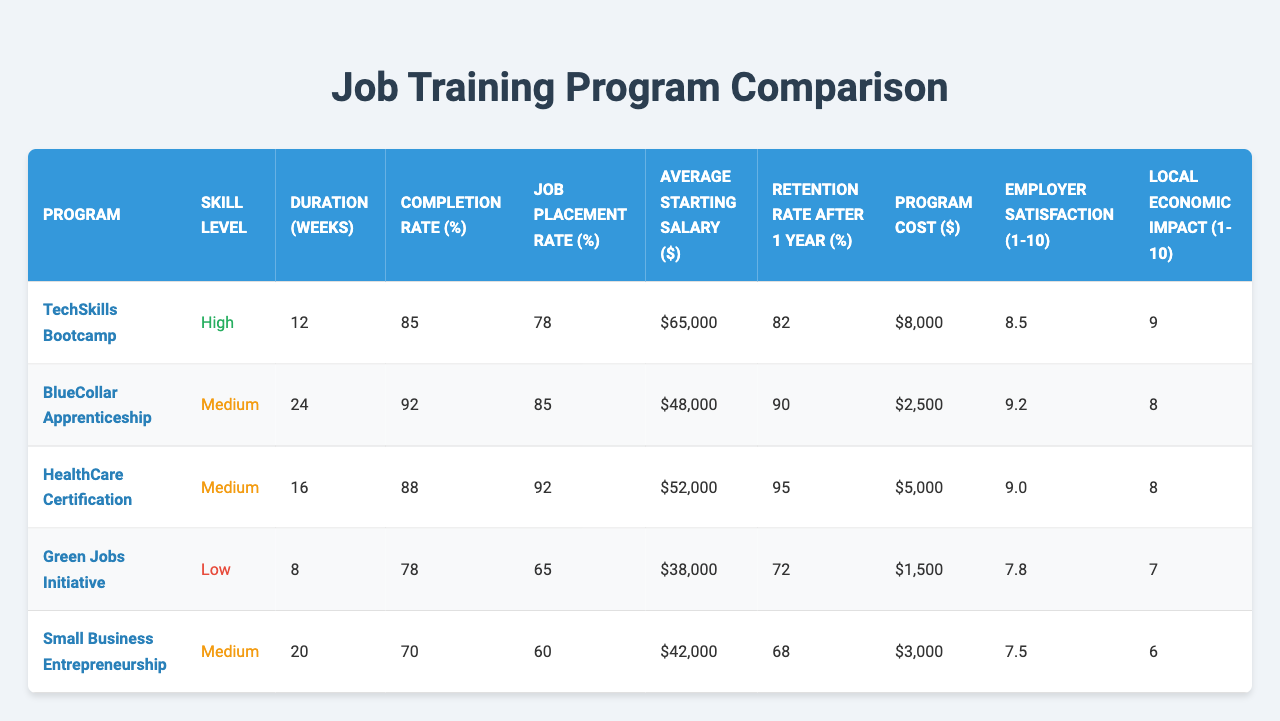What's the job placement rate for the TechSkills Bootcamp? The job placement rate is listed directly in the table under the "Job Placement Rate (%)" column for the TechSkills Bootcamp program, which is 78%.
Answer: 78% Which program has the highest completion rate? By comparing the "Completion Rate (%)" values across all programs, the BlueCollar Apprenticeship has the highest completion rate at 92%.
Answer: BlueCollar Apprenticeship What is the average starting salary for the HealthCare Certification program? The "Average Starting Salary ($)" for the HealthCare Certification program is explicitly noted in the table as $52,000.
Answer: $52,000 What is the difference in job placement rate between the highest and lowest programs? The highest job placement rate is 92% for HealthCare Certification, and the lowest is 60% for Small Business Entrepreneurship. The difference is 92% - 60% = 32%.
Answer: 32% Is the retention rate after one year for the BlueCollar Apprenticeship higher than the average for all programs? The retention rate for the BlueCollar Apprenticeship is 90%. To determine if this is above average, calculate the average retention rate: (82 + 90 + 95 + 72 + 68)/5 = 81.4%. Since 90% is greater than 81.4%, the answer is yes.
Answer: Yes What is the average program cost when combining all programs? To calculate the average program cost, sum all the costs: (8000 + 2500 + 5000 + 1500 + 3000) = 20000. Then divide by the number of programs (5): 20000/5 = 4000.
Answer: $4,000 Which skill level program has the lowest average starting salary? By examining the "Average Starting Salary ($)" for each program, the Green Jobs Initiative at a salary of $38,000 has the lowest starting salary among the listed programs.
Answer: Green Jobs Initiative Does any program have an employer satisfaction rating of 9 or higher? The table lists employer satisfaction ratings, and both the BlueCollar Apprenticeship (9.2) and HealthCare Certification (9.0) have ratings of 9 or higher.
Answer: Yes What is the local economic impact rating of the Small Business Entrepreneurship program? The local economic impact is listed in the table, and for the Small Business Entrepreneurship program, the rating is 6.
Answer: 6 Which program has the longest duration, and what is that duration? Looking at the "Duration (weeks)" column, the BlueCollar Apprenticeship has the longest duration at 24 weeks.
Answer: 24 weeks If the average starting salary for the TechSkills Bootcamp and HealthCare Certification programs is calculated, what would it be? The average starting salary is calculated by adding the starting salaries: (65000 + 52000) = 117000, then dividing by 2 (the number of programs): 117000/2 = 58500.
Answer: $58,500 